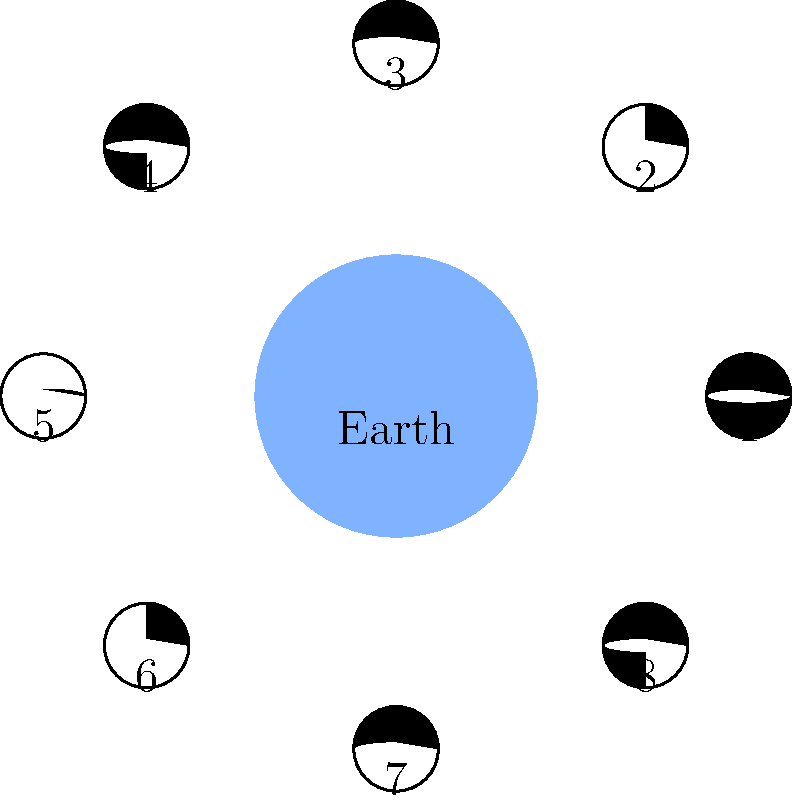As a C# student organizing a study session on astronomy, you're explaining the phases of the Moon. In the diagram, Earth is at the center, and the Moon's phases are shown in a circle around it. Which number represents the Full Moon phase, and what is its position relative to Earth and the Sun? To answer this question, let's analyze the diagram step-by-step:

1. The diagram shows Earth at the center and 8 phases of the Moon arranged in a circle around it.

2. The Moon phases are numbered from 1 to 8.

3. The shaded part of each Moon representation indicates the part that is not visible from Earth (the dark side).

4. The Full Moon occurs when the entire face of the Moon visible from Earth is illuminated.

5. Looking at the diagram, we can see that position 5 shows a completely illuminated Moon.

6. To understand the position relative to Earth and the Sun:
   - The Sun's light comes from the direction opposite to the shaded parts of the Moon.
   - For a Full Moon, the Earth must be between the Sun and the Moon.

7. In this configuration (position 5), the Sun would be to the left of Earth, Earth in the middle, and the Full Moon to the right of Earth.

Therefore, the Full Moon is represented by number 5 in the diagram, and it is positioned on the opposite side of Earth from the Sun.
Answer: 5; opposite Earth from Sun 